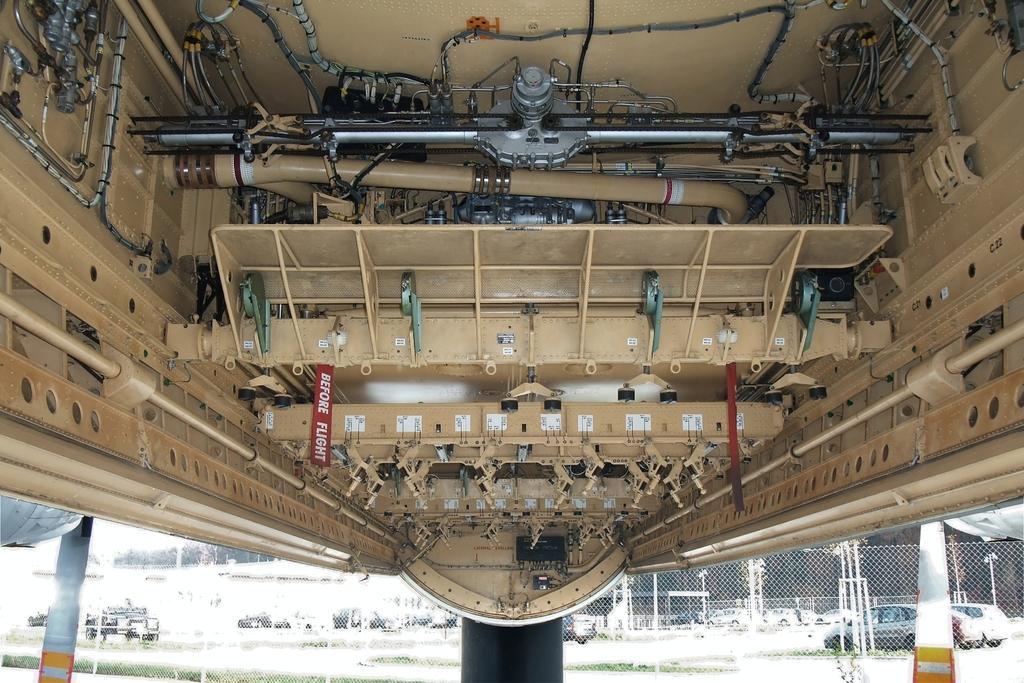In one or two sentences, can you explain what this image depicts? In the picture we can see a under the aircraft with some pipes, machines and some wires and behind the aircraft and behind it, we can see a fencing and behind it we can see some cars parked. 